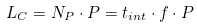<formula> <loc_0><loc_0><loc_500><loc_500>L _ { C } = N _ { P } \cdot P = t _ { i n t } \cdot f \cdot P</formula> 